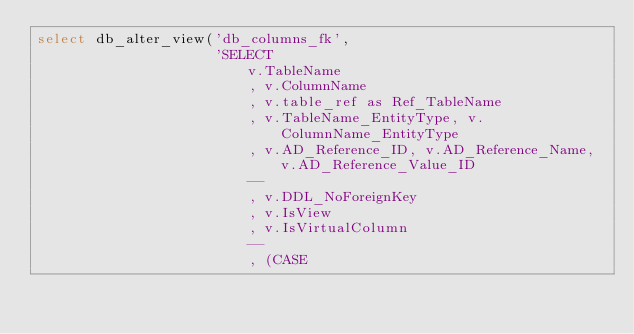Convert code to text. <code><loc_0><loc_0><loc_500><loc_500><_SQL_>select db_alter_view('db_columns_fk',
                     'SELECT
                         v.TableName
                         , v.ColumnName
                         , v.table_ref as Ref_TableName
                         , v.TableName_EntityType, v.ColumnName_EntityType
                         , v.AD_Reference_ID, v.AD_Reference_Name, v.AD_Reference_Value_ID
                         --
                         , v.DDL_NoForeignKey
                         , v.IsView
                         , v.IsVirtualColumn
                         --
                         , (CASE</code> 